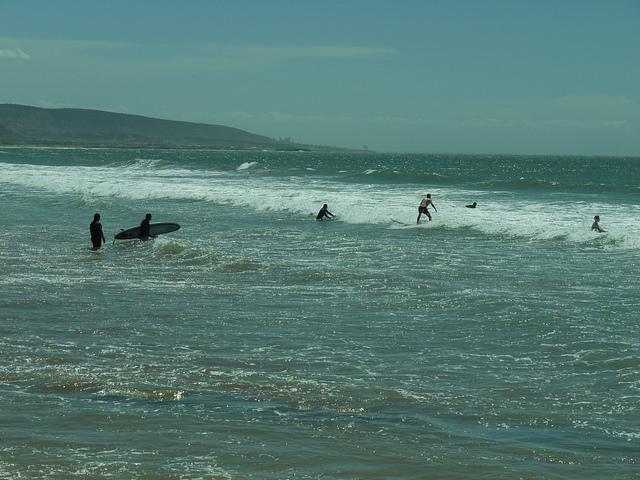What is the person holding?
Answer briefly. Surfboard. Are there many people in the ocean?
Short answer required. No. Are these people in a freshwater lake?
Short answer required. No. How many surfers are there?
Concise answer only. 6. What is this guy holding?
Quick response, please. Surfboard. 